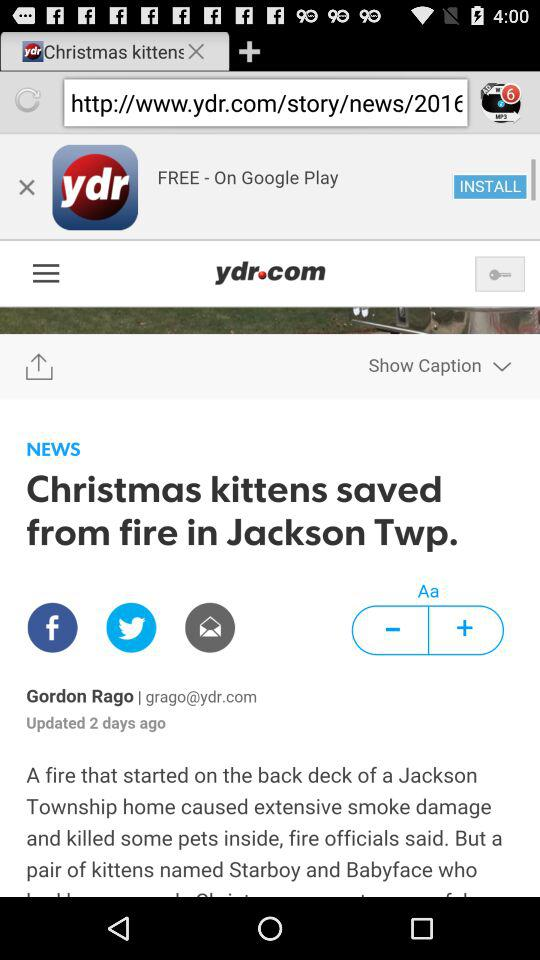What is the app name? The app name is "York Daily Record eNewspaper". 